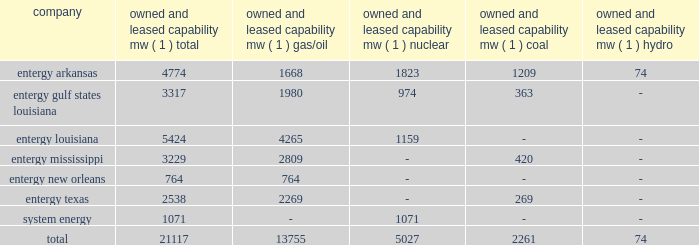Part i item 1 entergy corporation , utility operating companies , and system energy entergy new orleans provides electric and gas service in the city of new orleans pursuant to indeterminate permits set forth in city ordinances ( except electric service in algiers , which is provided by entergy louisiana ) .
These ordinances contain a continuing option for the city of new orleans to purchase entergy new orleans 2019s electric and gas utility properties .
Entergy texas holds a certificate of convenience and necessity from the puct to provide electric service to areas within approximately 27 counties in eastern texas , and holds non-exclusive franchises to provide electric service in approximately 68 incorporated municipalities .
Entergy texas was typically granted 50-year franchises , but recently has been receiving 25-year franchises .
Entergy texas 2019s electric franchises expire during 2013-2058 .
The business of system energy is limited to wholesale power sales .
It has no distribution franchises .
Property and other generation resources generating stations the total capability of the generating stations owned and leased by the utility operating companies and system energy as of december 31 , 2011 , is indicated below: .
( 1 ) 201cowned and leased capability 201d is the dependable load carrying capability as demonstrated under actual operating conditions based on the primary fuel ( assuming no curtailments ) that each station was designed to utilize .
The entergy system's load and capacity projections are reviewed periodically to assess the need and timing for additional generating capacity and interconnections .
These reviews consider existing and projected demand , the availability and price of power , the location of new load , and the economy .
Summer peak load in the entergy system service territory has averaged 21246 mw from 2002-2011 .
In the 2002 time period , the entergy system's long-term capacity resources , allowing for an adequate reserve margin , were approximately 3000 mw less than the total capacity required for peak period demands .
In this time period the entergy system met its capacity shortages almost entirely through short-term power purchases in the wholesale spot market .
In the fall of 2002 , the entergy system began a program to add new resources to its existing generation portfolio and began a process of issuing requests for proposals ( rfp ) to procure supply-side resources from sources other than the spot market to meet the unique regional needs of the utility operating companies .
The entergy system has adopted a long-term resource strategy that calls for the bulk of capacity needs to be met through long-term resources , whether owned or contracted .
Entergy refers to this strategy as the "portfolio transformation strategy" .
Over the past nine years , portfolio transformation has resulted in the addition of about 4500 mw of new long-term resources .
These figures do not include transactions currently pending as a result of the summer 2009 rfp .
When the summer 2009 rfp transactions are included in the entergy system portfolio of long-term resources and adjusting for unit deactivations of older generation , the entergy system is approximately 500 mw short of its projected 2012 peak load plus reserve margin .
This remaining need is expected to be met through a nuclear uprate at grand gulf and limited-term resources .
The entergy system will continue to access the spot power market to economically .
What portion of the total capabilities is generated from nuclear station for entergy as a whole? 
Computations: (5027 / 21117)
Answer: 0.23805. 